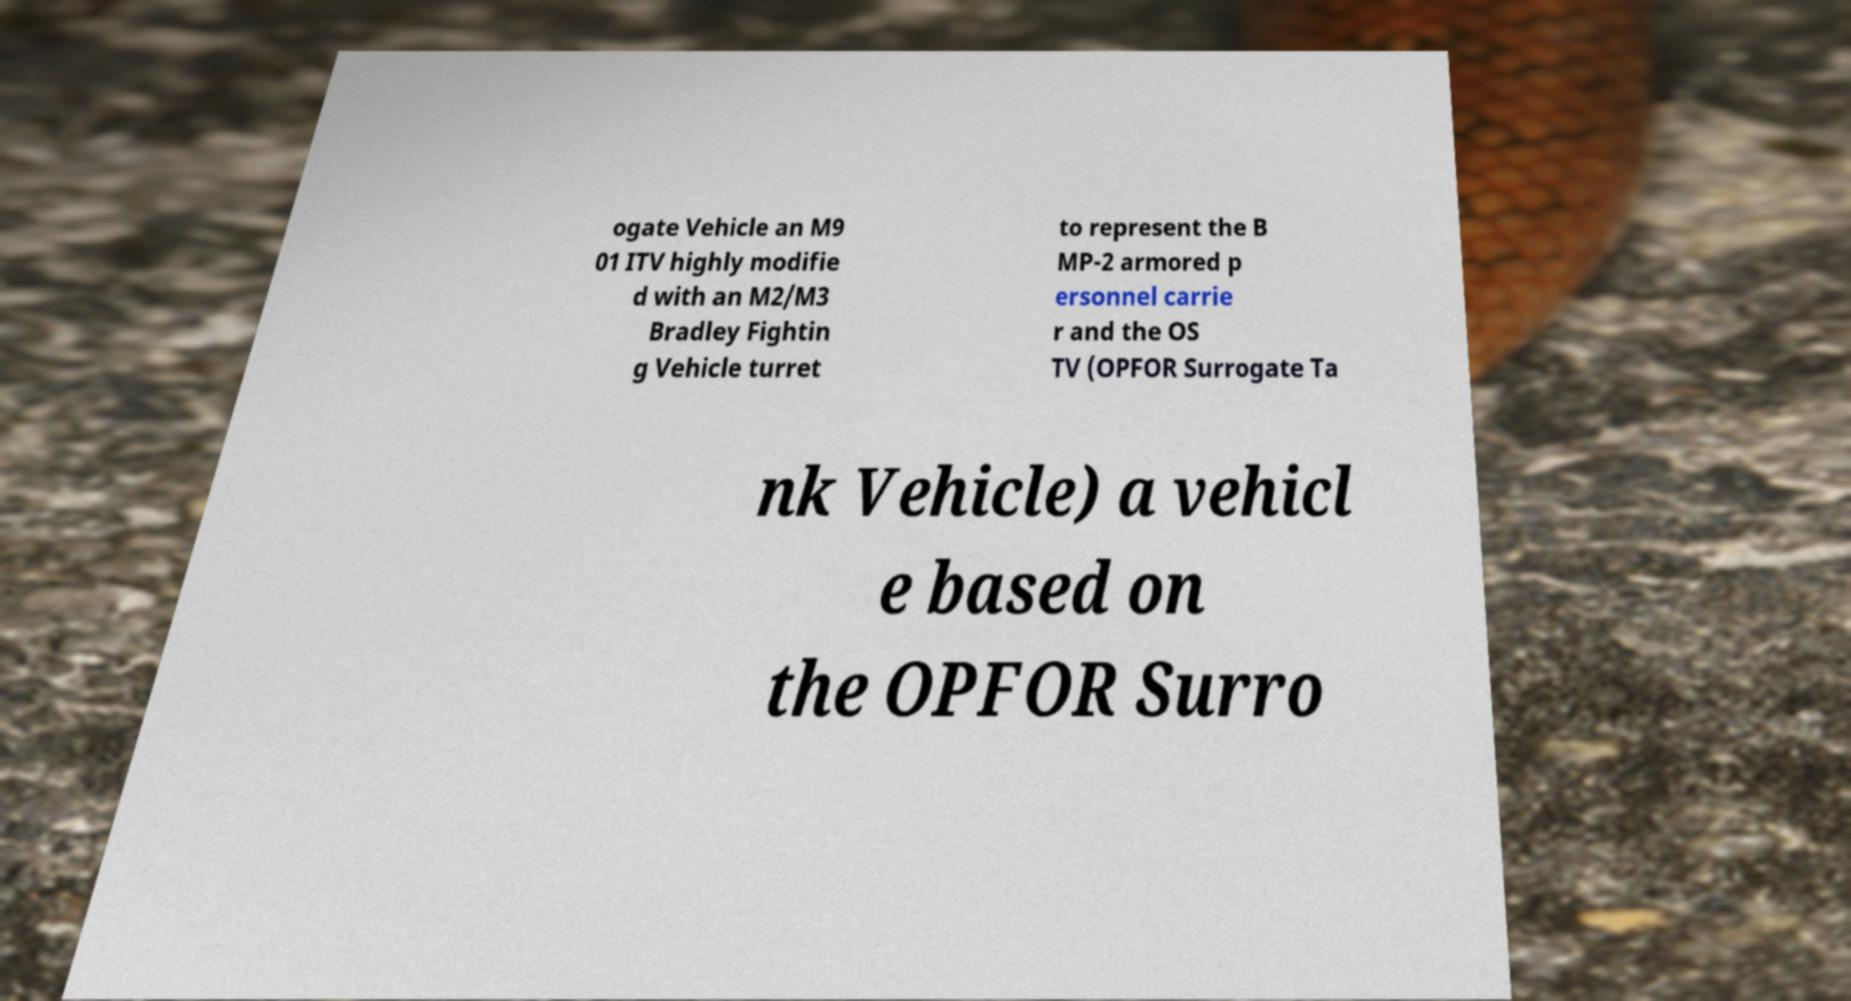Please identify and transcribe the text found in this image. ogate Vehicle an M9 01 ITV highly modifie d with an M2/M3 Bradley Fightin g Vehicle turret to represent the B MP-2 armored p ersonnel carrie r and the OS TV (OPFOR Surrogate Ta nk Vehicle) a vehicl e based on the OPFOR Surro 